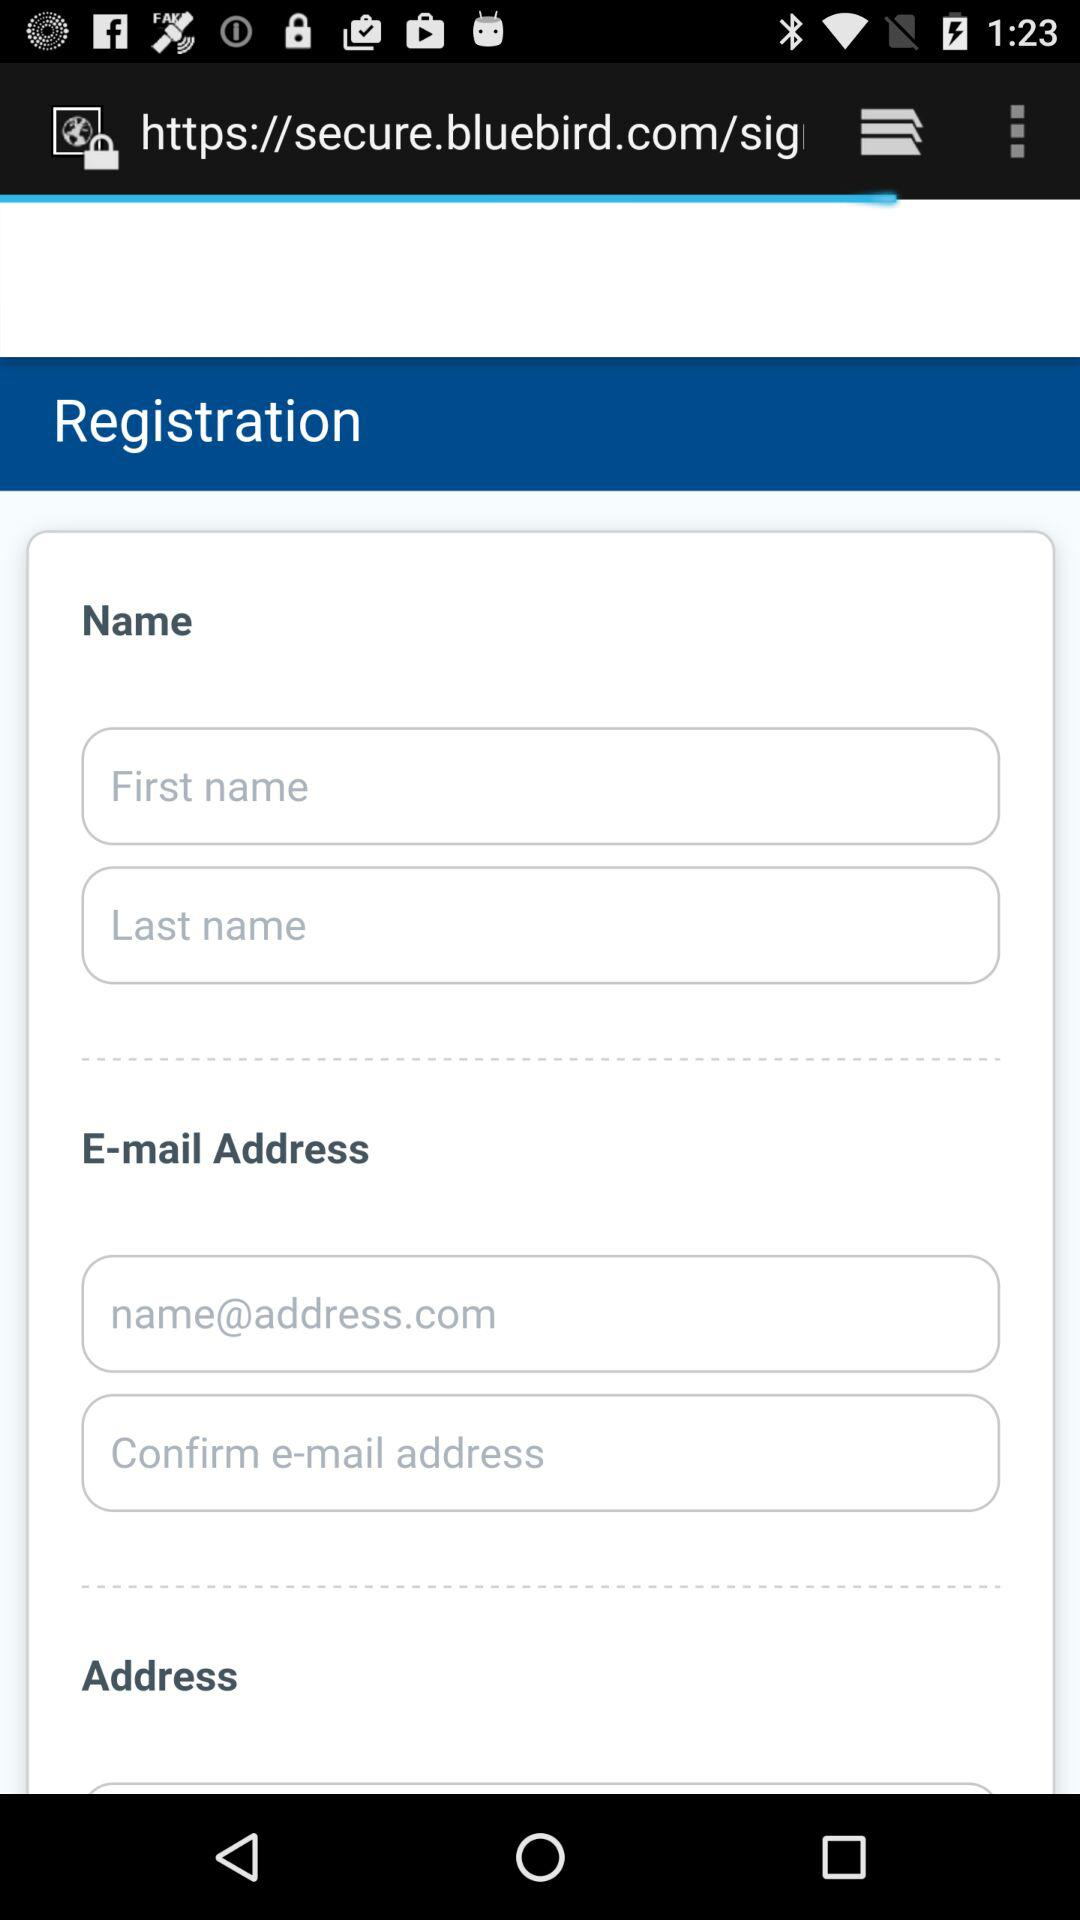What is the email address? The email address is name@address.com. 